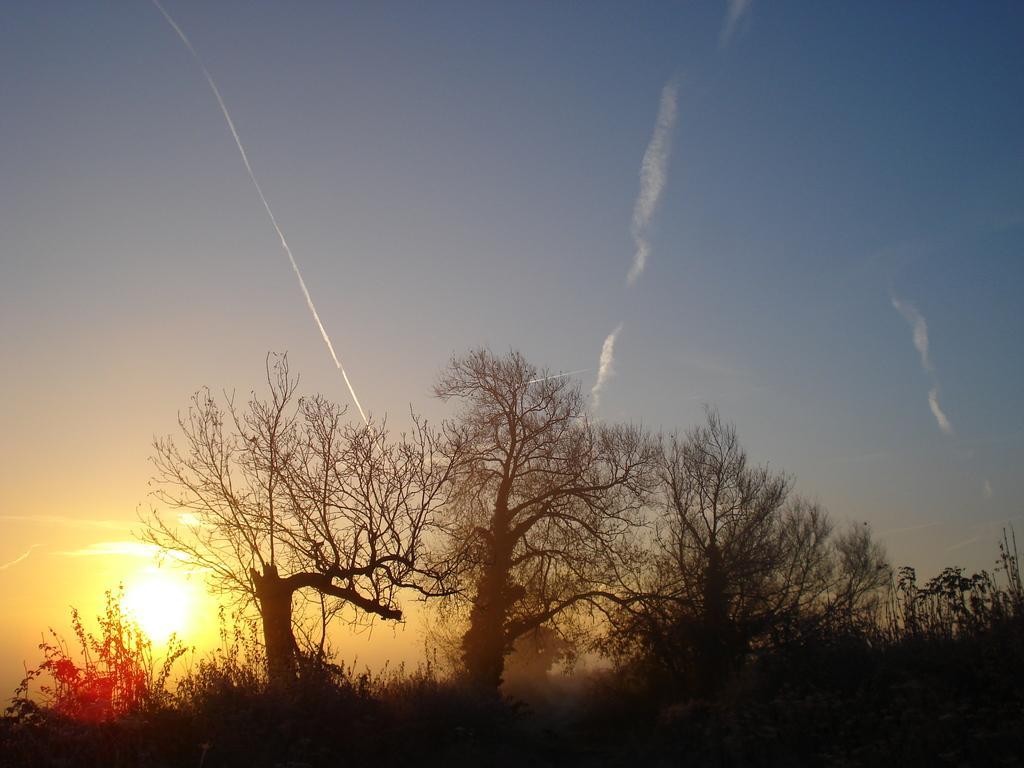How would you summarize this image in a sentence or two? In this image we can see some trees and plants, in the background we can see sunset and the sky. 